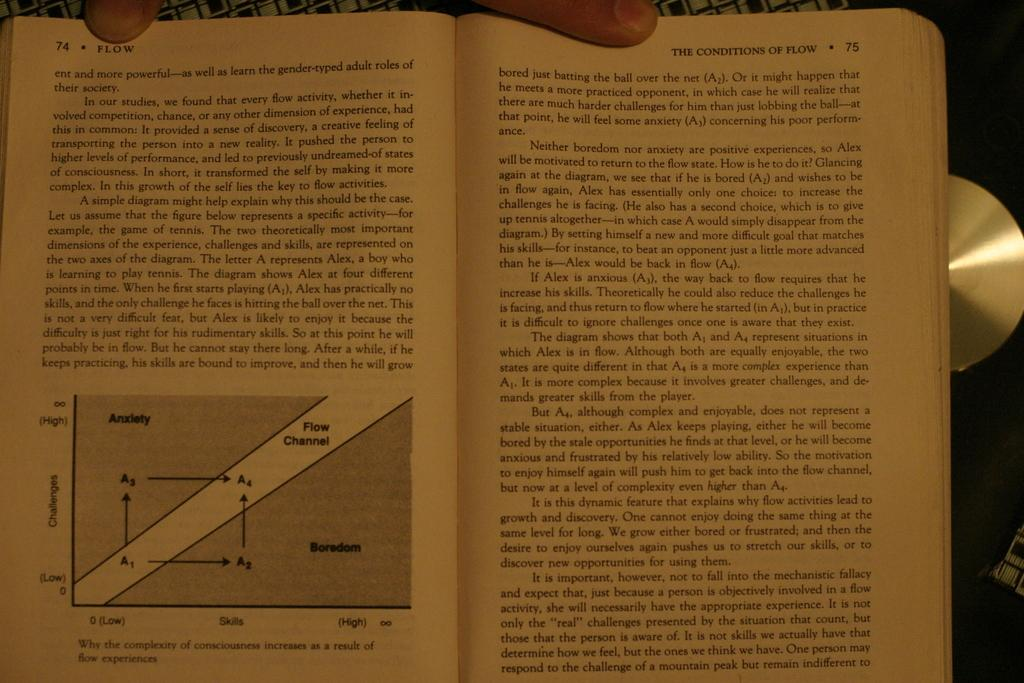<image>
Create a compact narrative representing the image presented. A book dealing with THE CONDITIONS OF FLOW is opened to pages 74 and 75. 